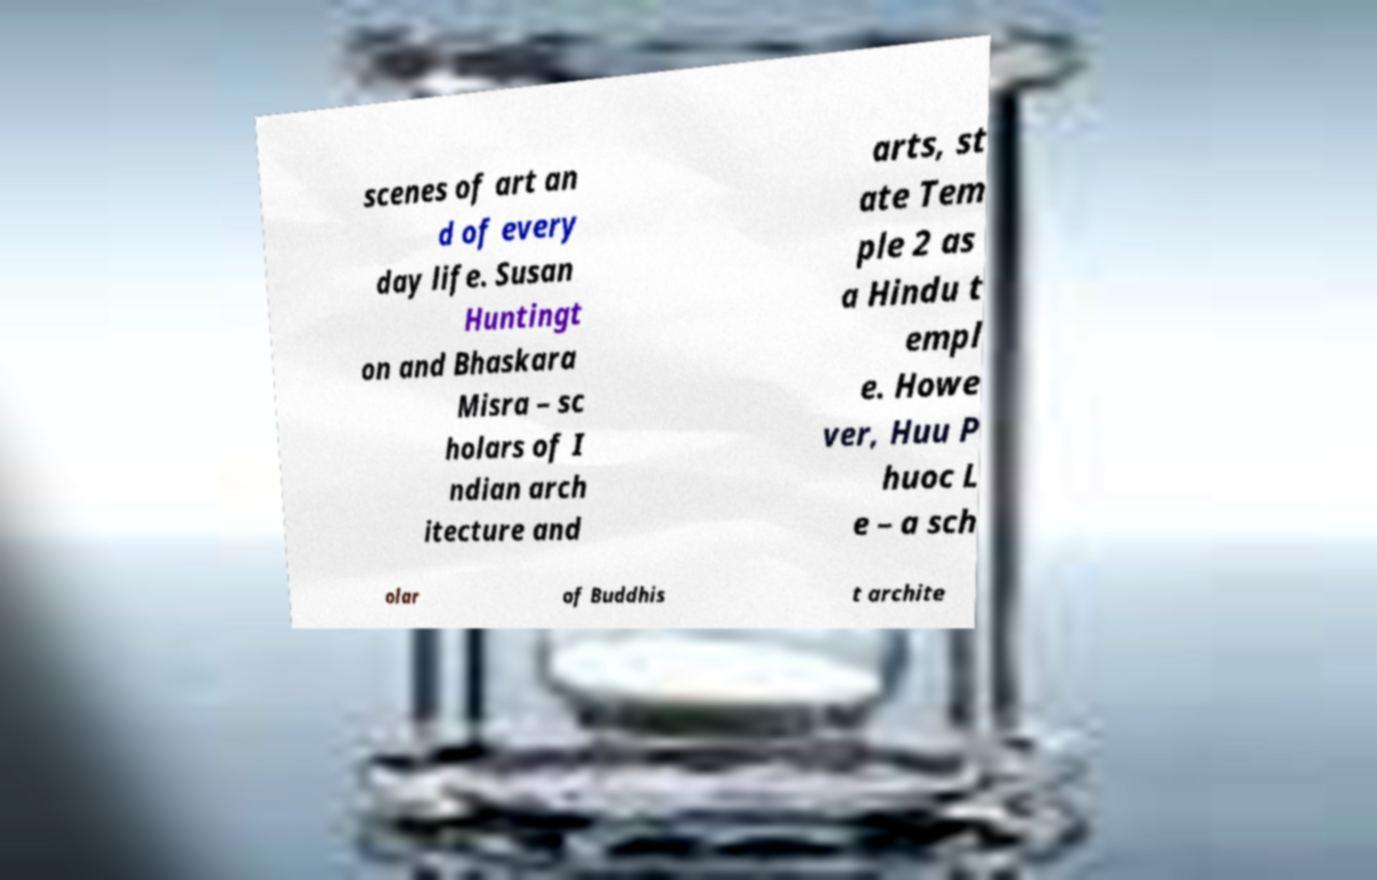Could you extract and type out the text from this image? scenes of art an d of every day life. Susan Huntingt on and Bhaskara Misra – sc holars of I ndian arch itecture and arts, st ate Tem ple 2 as a Hindu t empl e. Howe ver, Huu P huoc L e – a sch olar of Buddhis t archite 